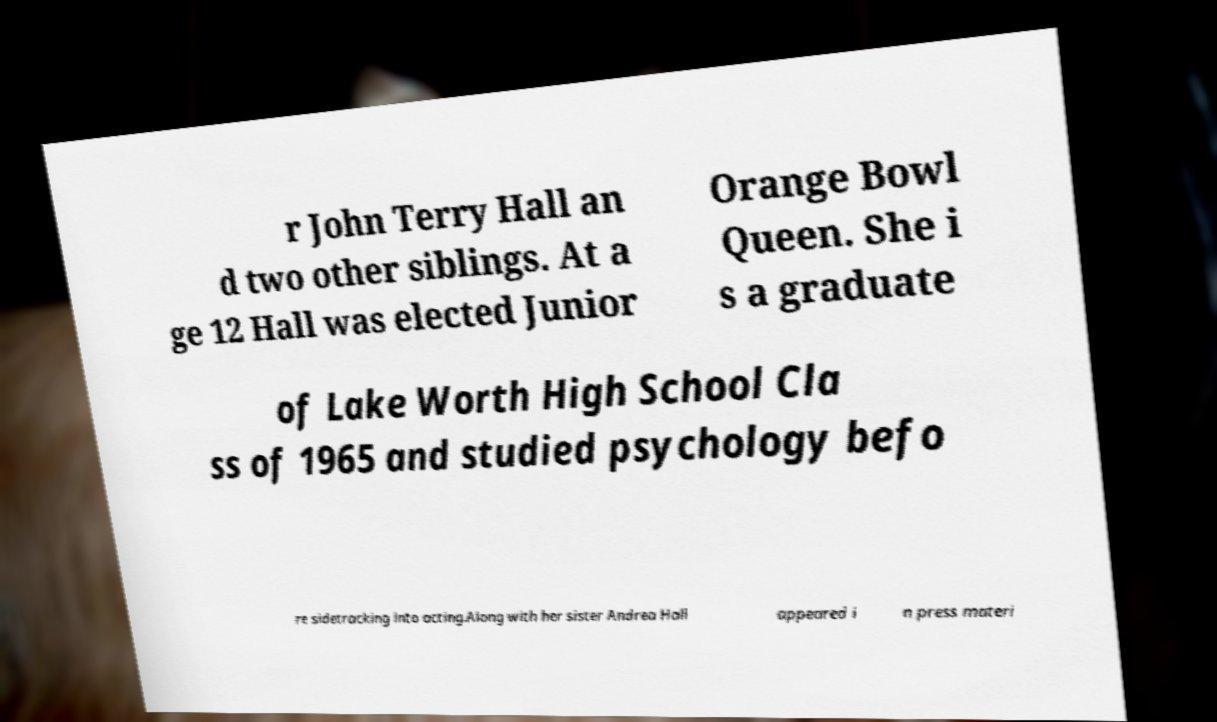I need the written content from this picture converted into text. Can you do that? r John Terry Hall an d two other siblings. At a ge 12 Hall was elected Junior Orange Bowl Queen. She i s a graduate of Lake Worth High School Cla ss of 1965 and studied psychology befo re sidetracking into acting.Along with her sister Andrea Hall appeared i n press materi 